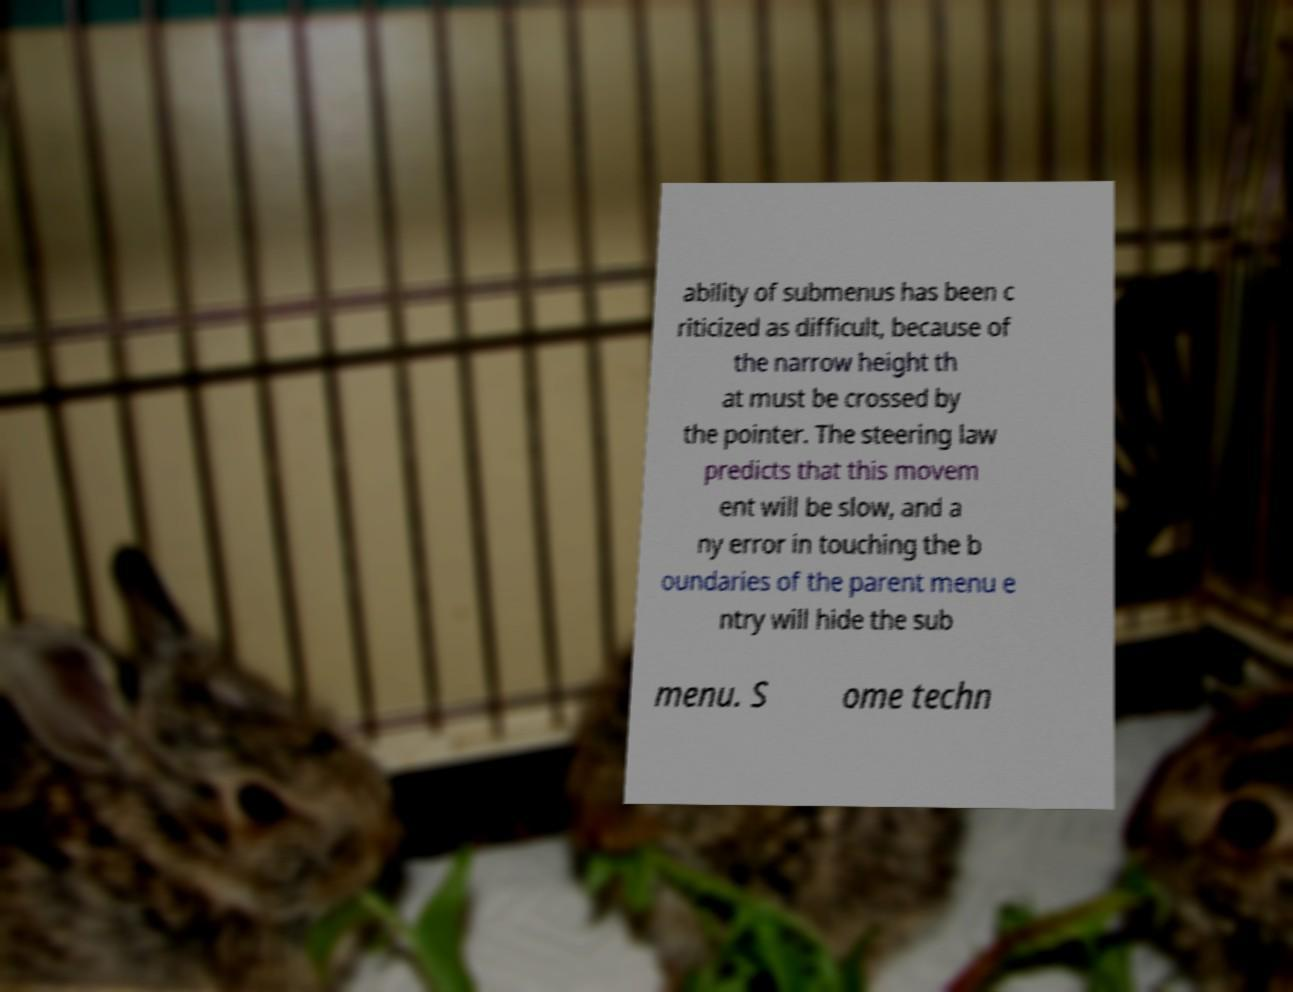Could you extract and type out the text from this image? ability of submenus has been c riticized as difficult, because of the narrow height th at must be crossed by the pointer. The steering law predicts that this movem ent will be slow, and a ny error in touching the b oundaries of the parent menu e ntry will hide the sub menu. S ome techn 